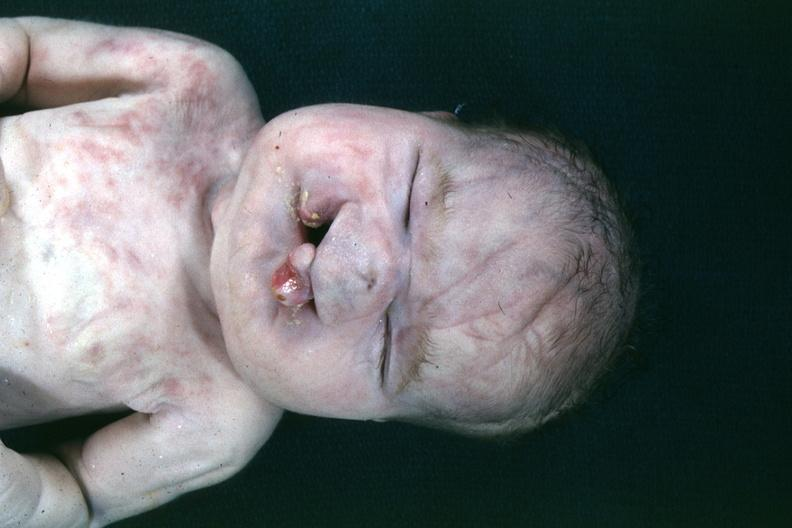s face present?
Answer the question using a single word or phrase. Yes 